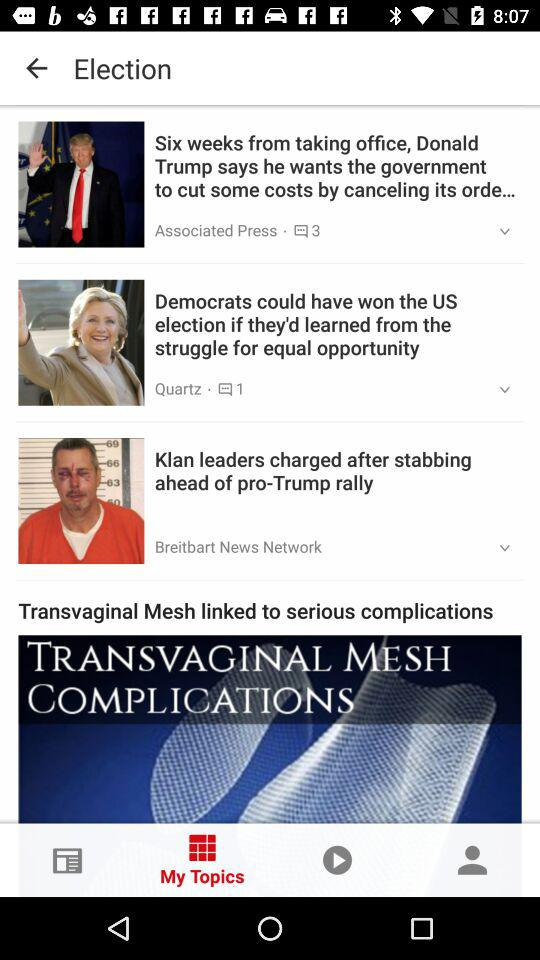How many news articles are there that are not by Associated Press?
Answer the question using a single word or phrase. 2 